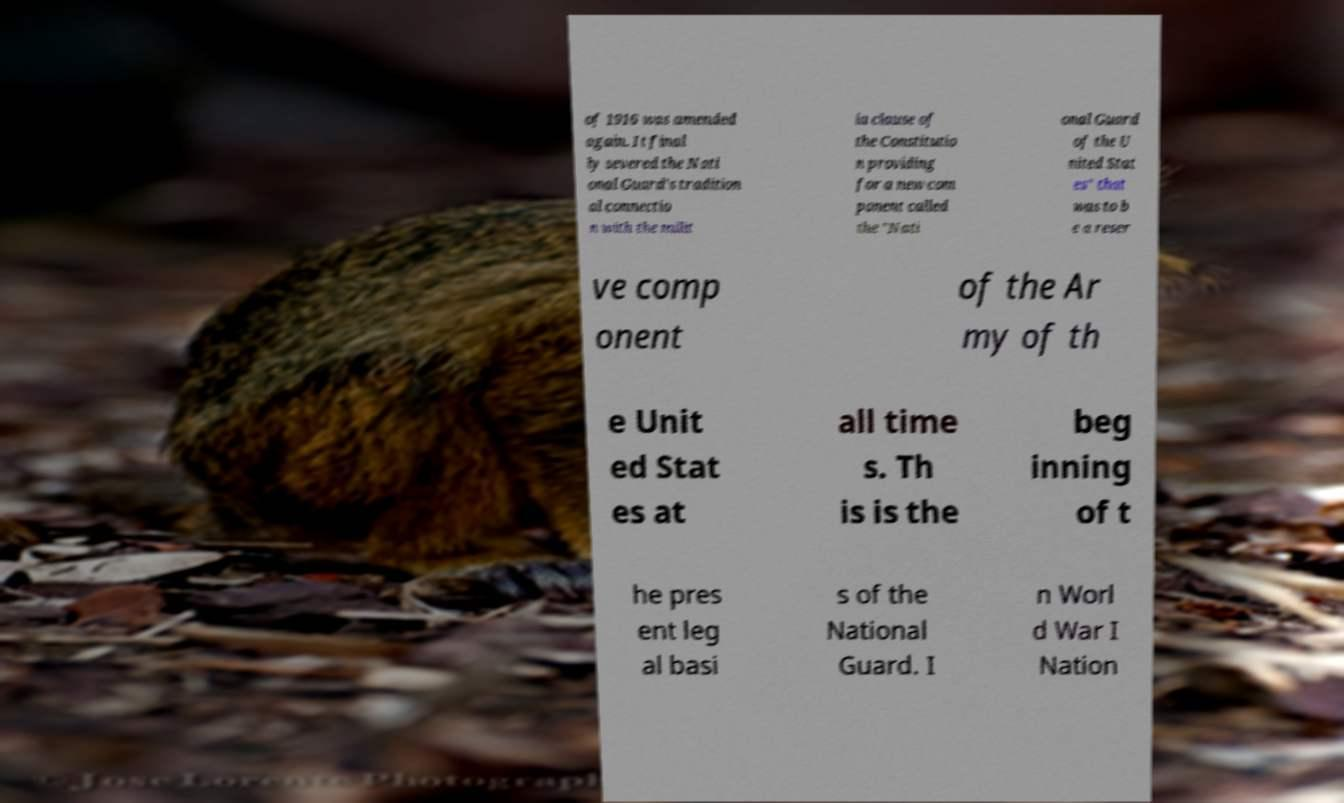I need the written content from this picture converted into text. Can you do that? of 1916 was amended again. It final ly severed the Nati onal Guard's tradition al connectio n with the milit ia clause of the Constitutio n providing for a new com ponent called the "Nati onal Guard of the U nited Stat es" that was to b e a reser ve comp onent of the Ar my of th e Unit ed Stat es at all time s. Th is is the beg inning of t he pres ent leg al basi s of the National Guard. I n Worl d War I Nation 